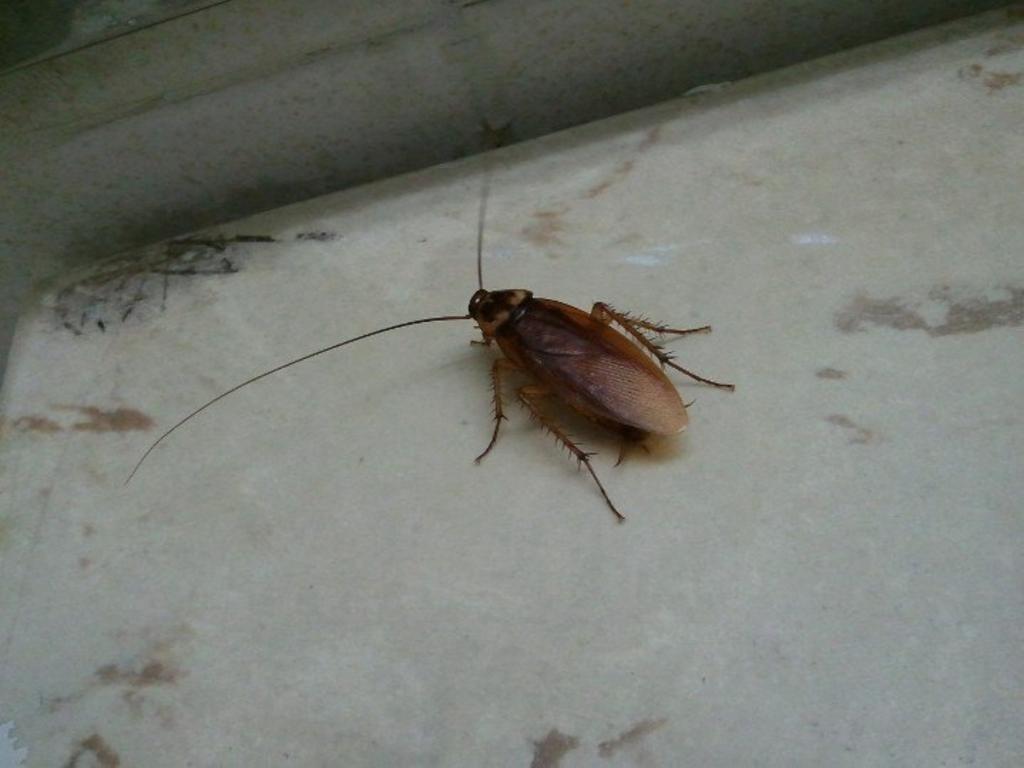Can you describe this image briefly? In this image I can see a cockroach on the floor. 